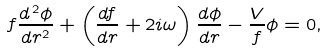<formula> <loc_0><loc_0><loc_500><loc_500>f \frac { d ^ { \, 2 } \phi } { d r ^ { 2 } } + \left ( \frac { d f } { d r } + 2 i \omega \right ) \frac { d \phi } { d r } - \frac { V } { f } \phi = 0 ,</formula> 